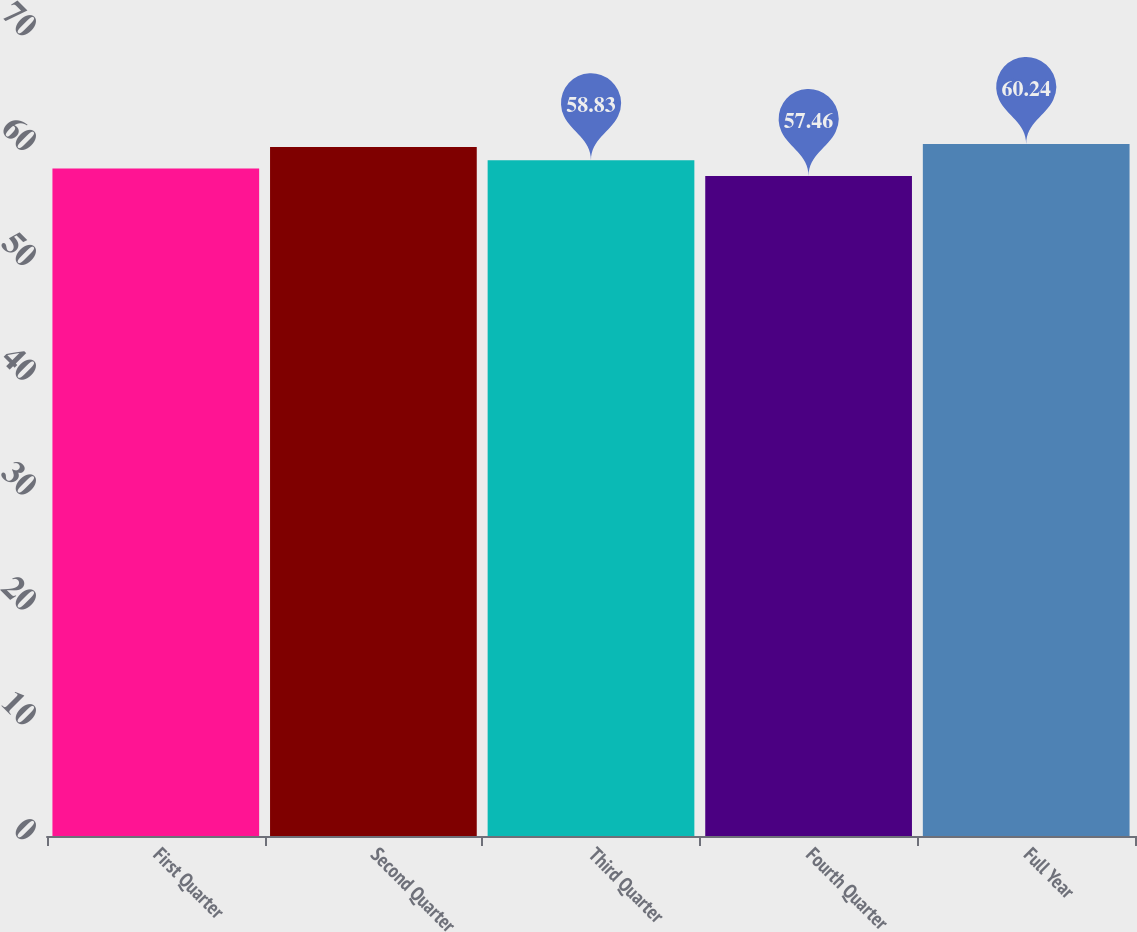<chart> <loc_0><loc_0><loc_500><loc_500><bar_chart><fcel>First Quarter<fcel>Second Quarter<fcel>Third Quarter<fcel>Fourth Quarter<fcel>Full Year<nl><fcel>58.11<fcel>59.99<fcel>58.83<fcel>57.46<fcel>60.24<nl></chart> 